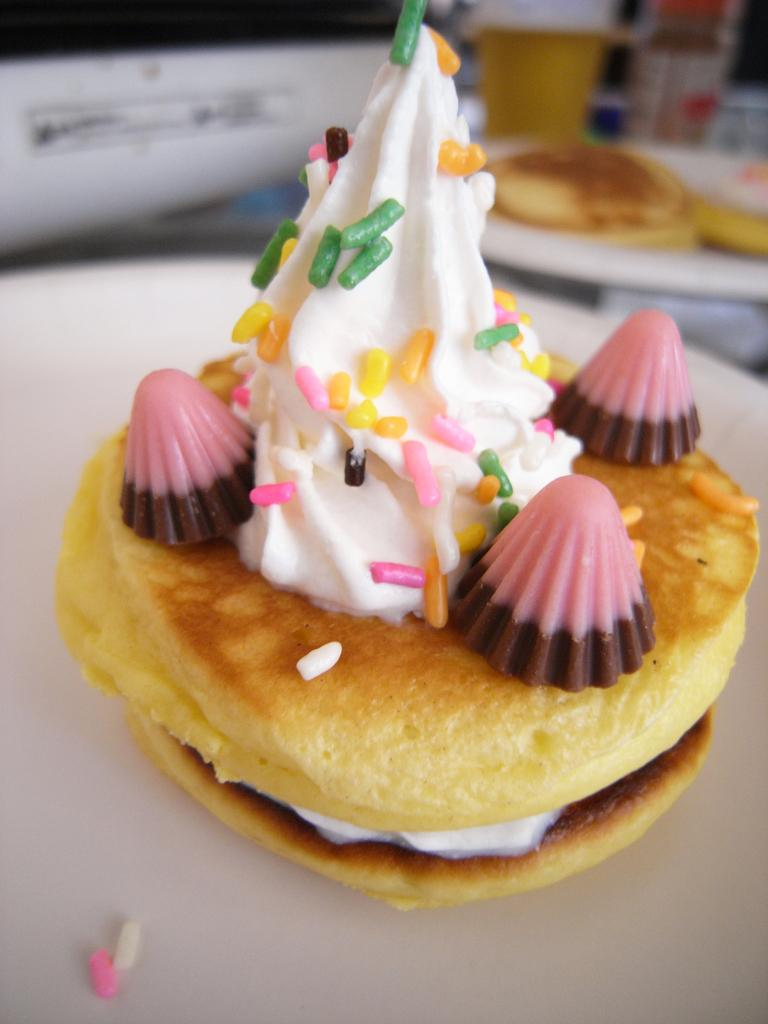What is the main subject of the image? There is food on a white surface in the image. What other objects can be seen in the background? There is a cup and a bottle in the background of the image. Are there any other plates with food in the image? Yes, there is food in another plate in the background of the image. What type of celery is being used as a baseball bat in the image? There is no celery or baseball bat present in the image. 